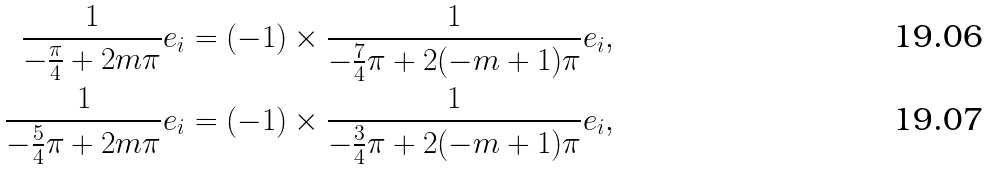<formula> <loc_0><loc_0><loc_500><loc_500>\frac { 1 } { - \frac { \pi } { 4 } + 2 m \pi } e _ { i } & = ( - 1 ) \times \frac { 1 } { - \frac { 7 } { 4 } \pi + 2 ( - m + 1 ) \pi } e _ { i } , \\ \frac { 1 } { - \frac { 5 } { 4 } \pi + 2 m \pi } e _ { i } & = ( - 1 ) \times \frac { 1 } { - \frac { 3 } { 4 } \pi + 2 ( - m + 1 ) \pi } e _ { i } ,</formula> 